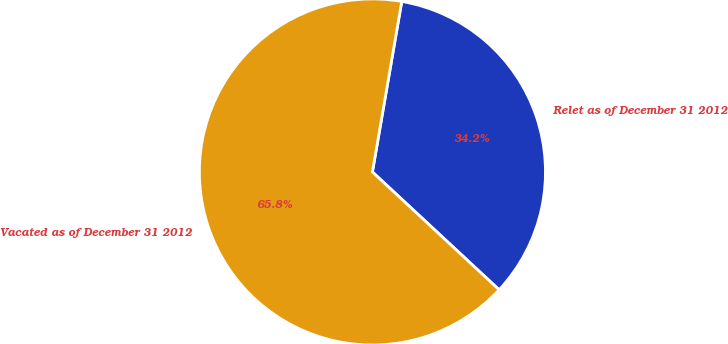Convert chart to OTSL. <chart><loc_0><loc_0><loc_500><loc_500><pie_chart><fcel>Relet as of December 31 2012<fcel>Vacated as of December 31 2012<nl><fcel>34.21%<fcel>65.79%<nl></chart> 